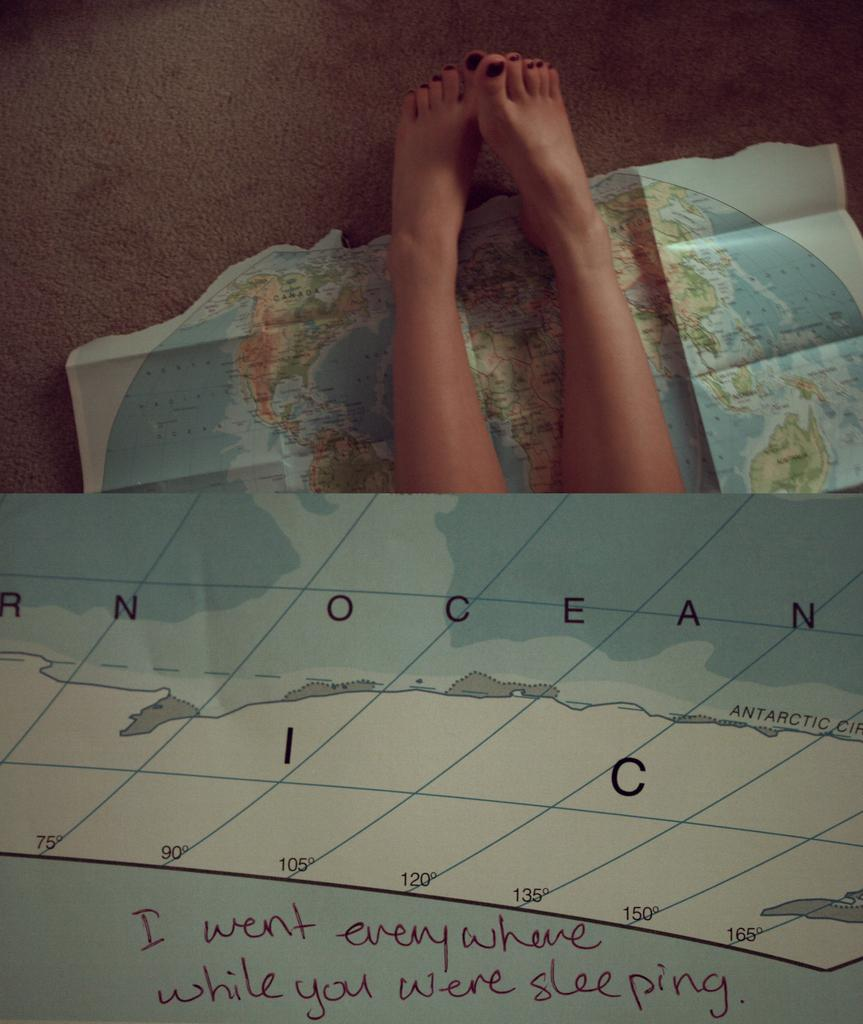What can be seen at the bottom of the image? There are legs of a person in the image. What type of object is present on a paper in the image? There is a map on a paper in the image. Is there any text or writing in the image? Yes, there is something written below the image. Can you describe the vein structure of the person's legs in the image? There is no information about the vein structure of the person's legs in the image. How does the person grip the map in the image? The image does not show the person's hands or how they are holding the map. 